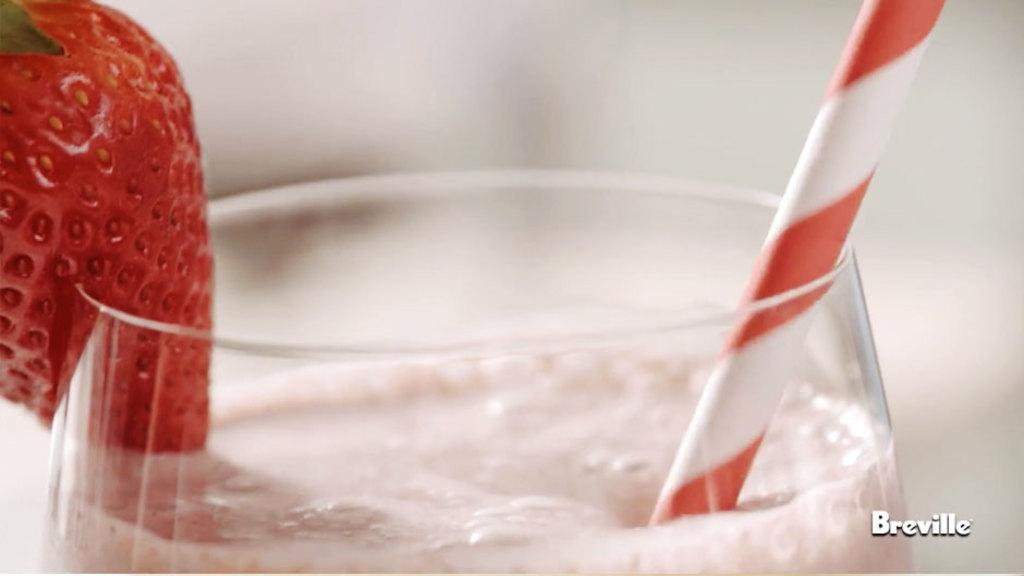What is the main object in the center of the image? There is a glass in the center of the image. What is inside the glass? The glass contains juice. Are there any additional elements in the glass? Yes, there are strawberries in the glass. How might someone consume the juice and strawberries in the glass? There is a straw in the glass, which can be used for drinking the juice. What arithmetic problem is solved on the watermark in the bottom right of the image? There is no arithmetic problem present on the watermark in the image. What invention is depicted in the image? The image does not depict any specific invention; it features a glass with juice, strawberries, and a straw. 